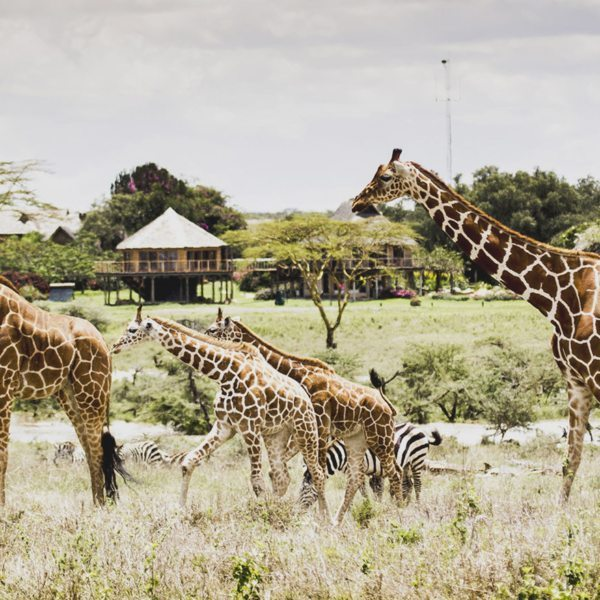The stilted structures seem special. Could they be designed for something beyond simple observation? Indeed, the stilted structures may serve multiple purposes. Besides offering an elevated viewpoint for wildlife observation, they could also provide accommodations for tourists, blending comfort with adventure in eco-lodges. These structures might include amenities like dining areas, lounge spaces, and even small libraries or education centers where guests learn more about the local flora and fauna. Their design often incorporates sustainable materials and practices, promoting conservation and offering visitors an immersive experience into the heart of the savanna. 